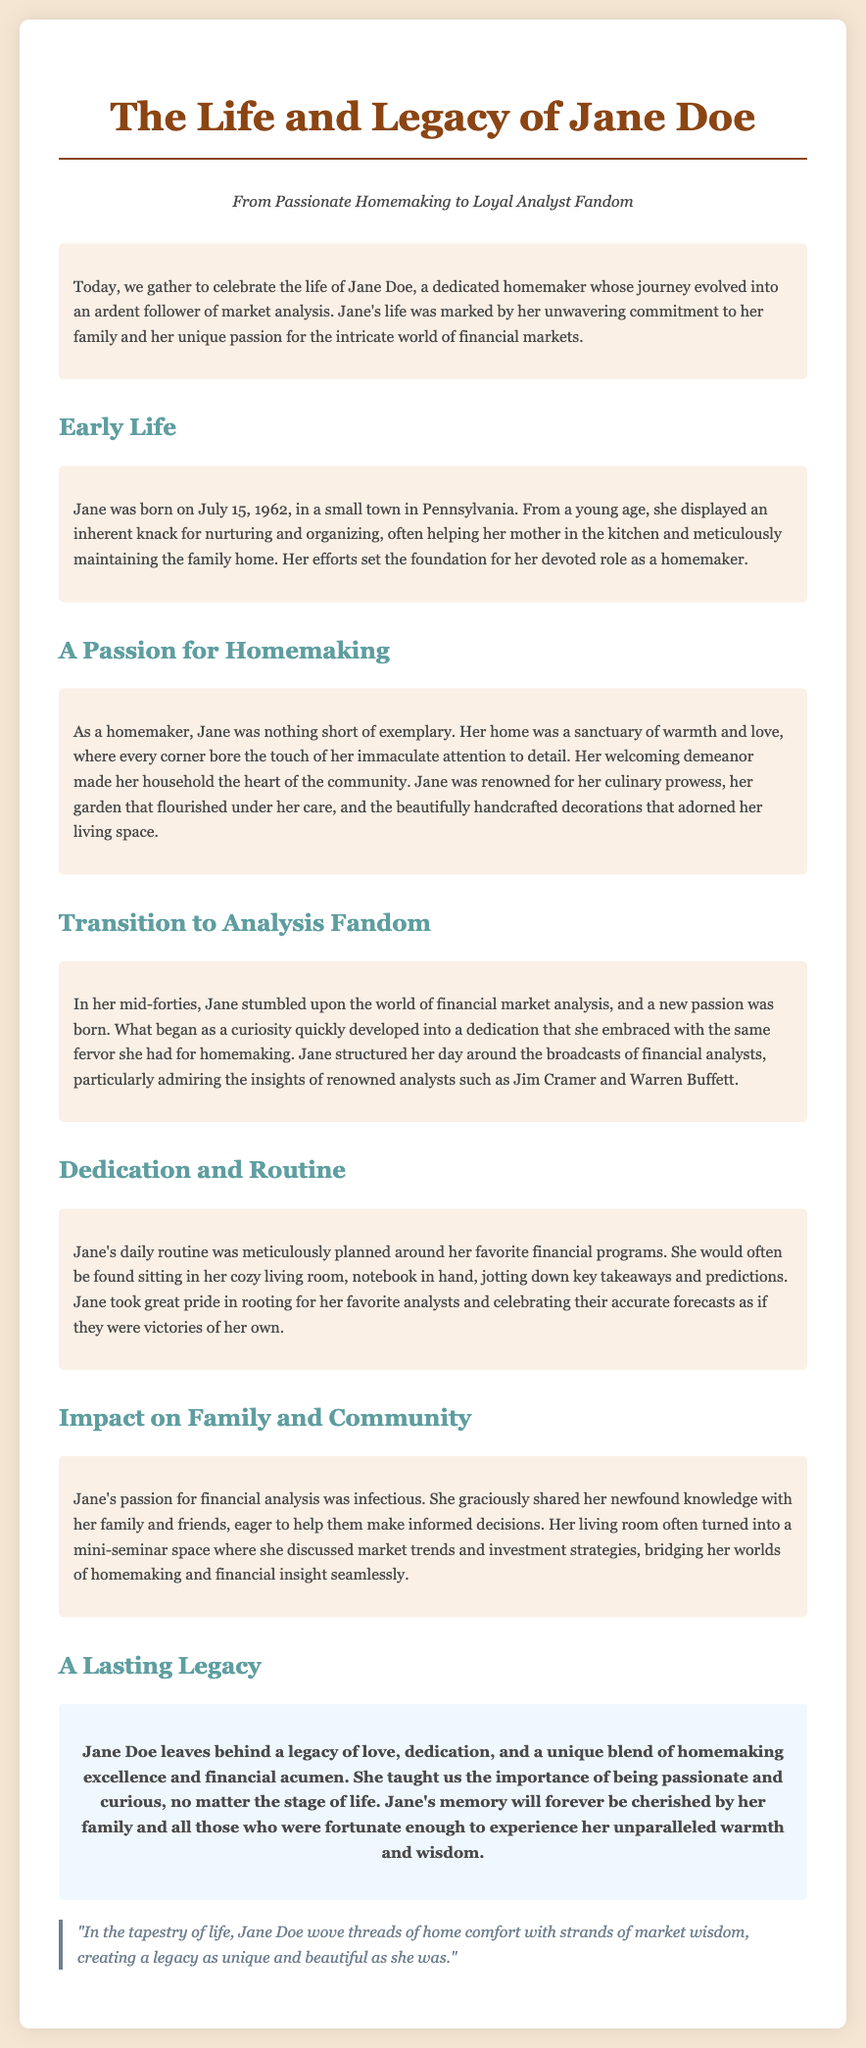what is the birth date of Jane Doe? Jane Doe was born on July 15, 1962, as stated in the document.
Answer: July 15, 1962 what role did Jane excel in at home? The document describes Jane as an exemplary homemaker, highlighting her attention to detail and culinary prowess.
Answer: Homemaker which analysts did Jane admire? The document mentions that Jane admired financial analysts such as Jim Cramer and Warren Buffett.
Answer: Jim Cramer and Warren Buffett what did Jane use to take notes during financial broadcasts? Jane would be found sitting with a notebook in hand, jotting down key takeaways and predictions.
Answer: Notebook how did Jane share her knowledge with others? Jane graciously shared her newfound knowledge with family and friends, often discussing market trends in her living room.
Answer: Shared with family and friends what legacy did Jane leave behind? The document states that Jane leaves behind a legacy of love, dedication, and a unique blend of homemaking excellence and financial acumen.
Answer: Love and dedication how did Jane's passion for analysis affect her family? Jane's passion for financial analysis was infectious, leading her to help her family make informed decisions.
Answer: Helped family make decisions what phrase captures Jane's dual interests in the eulogy? The quote describes Jane's unique blend of home comfort and market wisdom, symbolizing her life's work and interests.
Answer: Tapestry of life what type of community role did Jane take on through her interests? The document notes that Jane's living room turned into a mini-seminar space for discussing market trends.
Answer: Mini-seminar space 